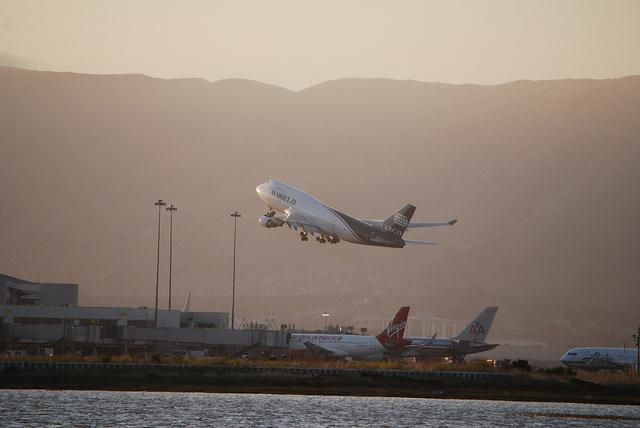Is this plane yellow?
Be succinct. No. Are there boats in the water?
Quick response, please. No. What airline is this?
Quick response, please. Virgin. What's natural landmark is in the background?
Write a very short answer. Mountain. What does it feel like to fly?
Give a very brief answer. Awesome. Is the sunset?
Quick response, please. No. Which airport is this?
Write a very short answer. Lax. Why is the airplane so close to the people?
Keep it brief. Taking off. How high is the plane?
Short answer required. 100 feet. Is this an amphibious aircraft?
Keep it brief. No. What is the tallest thing in the image?
Answer briefly. Mountain. Are the planes waiting for a storm to pass?
Concise answer only. No. 